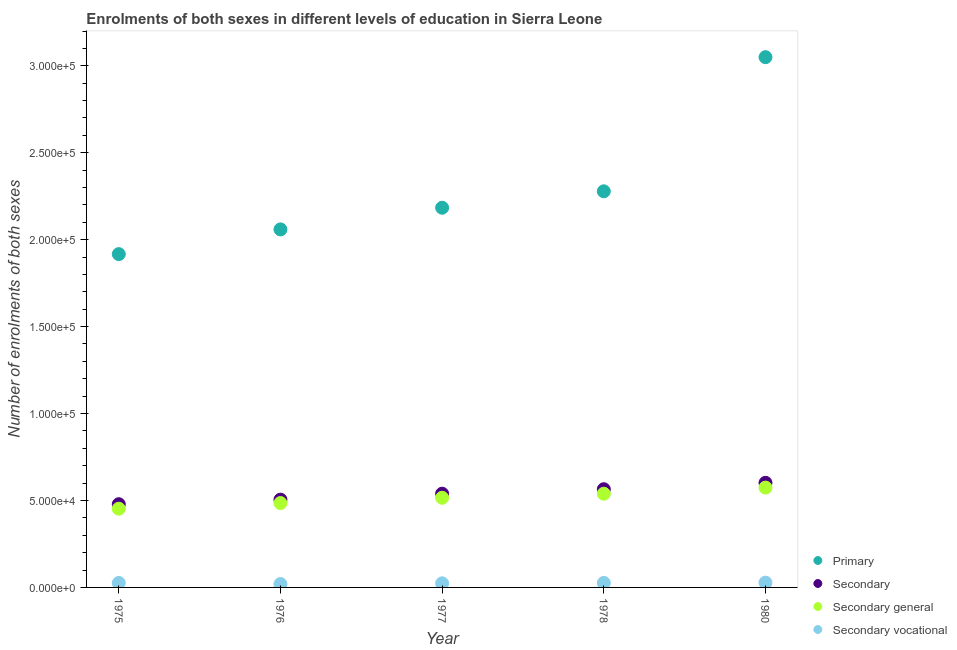How many different coloured dotlines are there?
Provide a short and direct response. 4. What is the number of enrolments in secondary education in 1976?
Offer a very short reply. 5.05e+04. Across all years, what is the maximum number of enrolments in primary education?
Provide a short and direct response. 3.05e+05. Across all years, what is the minimum number of enrolments in secondary general education?
Provide a short and direct response. 4.53e+04. In which year was the number of enrolments in primary education minimum?
Provide a succinct answer. 1975. What is the total number of enrolments in secondary general education in the graph?
Your response must be concise. 2.57e+05. What is the difference between the number of enrolments in primary education in 1977 and that in 1978?
Offer a terse response. -9439. What is the difference between the number of enrolments in secondary education in 1975 and the number of enrolments in secondary general education in 1976?
Your answer should be very brief. -673. What is the average number of enrolments in secondary general education per year?
Give a very brief answer. 5.13e+04. In the year 1980, what is the difference between the number of enrolments in secondary education and number of enrolments in secondary vocational education?
Make the answer very short. 5.74e+04. What is the ratio of the number of enrolments in secondary vocational education in 1976 to that in 1978?
Give a very brief answer. 0.75. Is the number of enrolments in secondary general education in 1977 less than that in 1980?
Your answer should be very brief. Yes. Is the difference between the number of enrolments in secondary general education in 1975 and 1980 greater than the difference between the number of enrolments in primary education in 1975 and 1980?
Offer a very short reply. Yes. What is the difference between the highest and the second highest number of enrolments in secondary general education?
Make the answer very short. 3517. What is the difference between the highest and the lowest number of enrolments in secondary general education?
Your answer should be very brief. 1.21e+04. In how many years, is the number of enrolments in secondary vocational education greater than the average number of enrolments in secondary vocational education taken over all years?
Your answer should be very brief. 3. Is the sum of the number of enrolments in secondary vocational education in 1976 and 1977 greater than the maximum number of enrolments in secondary education across all years?
Offer a terse response. No. Is it the case that in every year, the sum of the number of enrolments in primary education and number of enrolments in secondary education is greater than the number of enrolments in secondary general education?
Offer a very short reply. Yes. Does the graph contain grids?
Offer a very short reply. No. How many legend labels are there?
Give a very brief answer. 4. How are the legend labels stacked?
Your answer should be compact. Vertical. What is the title of the graph?
Ensure brevity in your answer.  Enrolments of both sexes in different levels of education in Sierra Leone. What is the label or title of the Y-axis?
Offer a very short reply. Number of enrolments of both sexes. What is the Number of enrolments of both sexes of Primary in 1975?
Offer a very short reply. 1.92e+05. What is the Number of enrolments of both sexes of Secondary in 1975?
Your answer should be compact. 4.79e+04. What is the Number of enrolments of both sexes in Secondary general in 1975?
Provide a short and direct response. 4.53e+04. What is the Number of enrolments of both sexes in Secondary vocational in 1975?
Offer a very short reply. 2584. What is the Number of enrolments of both sexes in Primary in 1976?
Provide a short and direct response. 2.06e+05. What is the Number of enrolments of both sexes in Secondary in 1976?
Ensure brevity in your answer.  5.05e+04. What is the Number of enrolments of both sexes of Secondary general in 1976?
Your answer should be compact. 4.85e+04. What is the Number of enrolments of both sexes in Secondary vocational in 1976?
Your response must be concise. 1944. What is the Number of enrolments of both sexes of Primary in 1977?
Provide a short and direct response. 2.18e+05. What is the Number of enrolments of both sexes in Secondary in 1977?
Provide a short and direct response. 5.39e+04. What is the Number of enrolments of both sexes of Secondary general in 1977?
Offer a very short reply. 5.16e+04. What is the Number of enrolments of both sexes in Secondary vocational in 1977?
Your answer should be compact. 2349. What is the Number of enrolments of both sexes in Primary in 1978?
Ensure brevity in your answer.  2.28e+05. What is the Number of enrolments of both sexes of Secondary in 1978?
Make the answer very short. 5.65e+04. What is the Number of enrolments of both sexes in Secondary general in 1978?
Provide a short and direct response. 5.39e+04. What is the Number of enrolments of both sexes in Secondary vocational in 1978?
Your answer should be compact. 2583. What is the Number of enrolments of both sexes of Primary in 1980?
Your response must be concise. 3.05e+05. What is the Number of enrolments of both sexes of Secondary in 1980?
Your response must be concise. 6.02e+04. What is the Number of enrolments of both sexes in Secondary general in 1980?
Keep it short and to the point. 5.74e+04. What is the Number of enrolments of both sexes of Secondary vocational in 1980?
Your answer should be compact. 2743. Across all years, what is the maximum Number of enrolments of both sexes of Primary?
Your answer should be very brief. 3.05e+05. Across all years, what is the maximum Number of enrolments of both sexes of Secondary?
Offer a terse response. 6.02e+04. Across all years, what is the maximum Number of enrolments of both sexes of Secondary general?
Offer a terse response. 5.74e+04. Across all years, what is the maximum Number of enrolments of both sexes of Secondary vocational?
Provide a short and direct response. 2743. Across all years, what is the minimum Number of enrolments of both sexes of Primary?
Provide a short and direct response. 1.92e+05. Across all years, what is the minimum Number of enrolments of both sexes in Secondary?
Offer a terse response. 4.79e+04. Across all years, what is the minimum Number of enrolments of both sexes in Secondary general?
Keep it short and to the point. 4.53e+04. Across all years, what is the minimum Number of enrolments of both sexes in Secondary vocational?
Keep it short and to the point. 1944. What is the total Number of enrolments of both sexes in Primary in the graph?
Provide a succinct answer. 1.15e+06. What is the total Number of enrolments of both sexes in Secondary in the graph?
Ensure brevity in your answer.  2.69e+05. What is the total Number of enrolments of both sexes in Secondary general in the graph?
Your response must be concise. 2.57e+05. What is the total Number of enrolments of both sexes of Secondary vocational in the graph?
Offer a very short reply. 1.22e+04. What is the difference between the Number of enrolments of both sexes in Primary in 1975 and that in 1976?
Offer a terse response. -1.42e+04. What is the difference between the Number of enrolments of both sexes in Secondary in 1975 and that in 1976?
Ensure brevity in your answer.  -2617. What is the difference between the Number of enrolments of both sexes of Secondary general in 1975 and that in 1976?
Give a very brief answer. -3257. What is the difference between the Number of enrolments of both sexes of Secondary vocational in 1975 and that in 1976?
Your answer should be compact. 640. What is the difference between the Number of enrolments of both sexes of Primary in 1975 and that in 1977?
Provide a succinct answer. -2.67e+04. What is the difference between the Number of enrolments of both sexes in Secondary in 1975 and that in 1977?
Make the answer very short. -6052. What is the difference between the Number of enrolments of both sexes of Secondary general in 1975 and that in 1977?
Ensure brevity in your answer.  -6287. What is the difference between the Number of enrolments of both sexes of Secondary vocational in 1975 and that in 1977?
Offer a terse response. 235. What is the difference between the Number of enrolments of both sexes of Primary in 1975 and that in 1978?
Your response must be concise. -3.61e+04. What is the difference between the Number of enrolments of both sexes of Secondary in 1975 and that in 1978?
Your answer should be compact. -8619. What is the difference between the Number of enrolments of both sexes in Secondary general in 1975 and that in 1978?
Make the answer very short. -8620. What is the difference between the Number of enrolments of both sexes in Secondary vocational in 1975 and that in 1978?
Ensure brevity in your answer.  1. What is the difference between the Number of enrolments of both sexes in Primary in 1975 and that in 1980?
Your answer should be very brief. -1.13e+05. What is the difference between the Number of enrolments of both sexes of Secondary in 1975 and that in 1980?
Give a very brief answer. -1.23e+04. What is the difference between the Number of enrolments of both sexes in Secondary general in 1975 and that in 1980?
Keep it short and to the point. -1.21e+04. What is the difference between the Number of enrolments of both sexes in Secondary vocational in 1975 and that in 1980?
Provide a succinct answer. -159. What is the difference between the Number of enrolments of both sexes of Primary in 1976 and that in 1977?
Give a very brief answer. -1.25e+04. What is the difference between the Number of enrolments of both sexes of Secondary in 1976 and that in 1977?
Give a very brief answer. -3435. What is the difference between the Number of enrolments of both sexes in Secondary general in 1976 and that in 1977?
Give a very brief answer. -3030. What is the difference between the Number of enrolments of both sexes of Secondary vocational in 1976 and that in 1977?
Your answer should be compact. -405. What is the difference between the Number of enrolments of both sexes of Primary in 1976 and that in 1978?
Provide a succinct answer. -2.19e+04. What is the difference between the Number of enrolments of both sexes in Secondary in 1976 and that in 1978?
Ensure brevity in your answer.  -6002. What is the difference between the Number of enrolments of both sexes in Secondary general in 1976 and that in 1978?
Your answer should be very brief. -5363. What is the difference between the Number of enrolments of both sexes of Secondary vocational in 1976 and that in 1978?
Provide a short and direct response. -639. What is the difference between the Number of enrolments of both sexes of Primary in 1976 and that in 1980?
Give a very brief answer. -9.91e+04. What is the difference between the Number of enrolments of both sexes in Secondary in 1976 and that in 1980?
Your answer should be compact. -9679. What is the difference between the Number of enrolments of both sexes of Secondary general in 1976 and that in 1980?
Ensure brevity in your answer.  -8880. What is the difference between the Number of enrolments of both sexes in Secondary vocational in 1976 and that in 1980?
Provide a succinct answer. -799. What is the difference between the Number of enrolments of both sexes in Primary in 1977 and that in 1978?
Ensure brevity in your answer.  -9439. What is the difference between the Number of enrolments of both sexes of Secondary in 1977 and that in 1978?
Make the answer very short. -2567. What is the difference between the Number of enrolments of both sexes of Secondary general in 1977 and that in 1978?
Ensure brevity in your answer.  -2333. What is the difference between the Number of enrolments of both sexes of Secondary vocational in 1977 and that in 1978?
Offer a very short reply. -234. What is the difference between the Number of enrolments of both sexes in Primary in 1977 and that in 1980?
Keep it short and to the point. -8.66e+04. What is the difference between the Number of enrolments of both sexes of Secondary in 1977 and that in 1980?
Your answer should be compact. -6244. What is the difference between the Number of enrolments of both sexes of Secondary general in 1977 and that in 1980?
Your answer should be very brief. -5850. What is the difference between the Number of enrolments of both sexes of Secondary vocational in 1977 and that in 1980?
Provide a short and direct response. -394. What is the difference between the Number of enrolments of both sexes in Primary in 1978 and that in 1980?
Give a very brief answer. -7.71e+04. What is the difference between the Number of enrolments of both sexes of Secondary in 1978 and that in 1980?
Keep it short and to the point. -3677. What is the difference between the Number of enrolments of both sexes in Secondary general in 1978 and that in 1980?
Keep it short and to the point. -3517. What is the difference between the Number of enrolments of both sexes of Secondary vocational in 1978 and that in 1980?
Offer a very short reply. -160. What is the difference between the Number of enrolments of both sexes in Primary in 1975 and the Number of enrolments of both sexes in Secondary in 1976?
Your response must be concise. 1.41e+05. What is the difference between the Number of enrolments of both sexes in Primary in 1975 and the Number of enrolments of both sexes in Secondary general in 1976?
Provide a short and direct response. 1.43e+05. What is the difference between the Number of enrolments of both sexes of Primary in 1975 and the Number of enrolments of both sexes of Secondary vocational in 1976?
Your answer should be very brief. 1.90e+05. What is the difference between the Number of enrolments of both sexes of Secondary in 1975 and the Number of enrolments of both sexes of Secondary general in 1976?
Make the answer very short. -673. What is the difference between the Number of enrolments of both sexes of Secondary in 1975 and the Number of enrolments of both sexes of Secondary vocational in 1976?
Your answer should be very brief. 4.59e+04. What is the difference between the Number of enrolments of both sexes in Secondary general in 1975 and the Number of enrolments of both sexes in Secondary vocational in 1976?
Provide a short and direct response. 4.33e+04. What is the difference between the Number of enrolments of both sexes of Primary in 1975 and the Number of enrolments of both sexes of Secondary in 1977?
Your answer should be very brief. 1.38e+05. What is the difference between the Number of enrolments of both sexes in Primary in 1975 and the Number of enrolments of both sexes in Secondary general in 1977?
Your answer should be very brief. 1.40e+05. What is the difference between the Number of enrolments of both sexes of Primary in 1975 and the Number of enrolments of both sexes of Secondary vocational in 1977?
Offer a terse response. 1.89e+05. What is the difference between the Number of enrolments of both sexes in Secondary in 1975 and the Number of enrolments of both sexes in Secondary general in 1977?
Keep it short and to the point. -3703. What is the difference between the Number of enrolments of both sexes in Secondary in 1975 and the Number of enrolments of both sexes in Secondary vocational in 1977?
Your response must be concise. 4.55e+04. What is the difference between the Number of enrolments of both sexes in Secondary general in 1975 and the Number of enrolments of both sexes in Secondary vocational in 1977?
Your answer should be very brief. 4.29e+04. What is the difference between the Number of enrolments of both sexes of Primary in 1975 and the Number of enrolments of both sexes of Secondary in 1978?
Your answer should be very brief. 1.35e+05. What is the difference between the Number of enrolments of both sexes in Primary in 1975 and the Number of enrolments of both sexes in Secondary general in 1978?
Offer a very short reply. 1.38e+05. What is the difference between the Number of enrolments of both sexes of Primary in 1975 and the Number of enrolments of both sexes of Secondary vocational in 1978?
Offer a very short reply. 1.89e+05. What is the difference between the Number of enrolments of both sexes in Secondary in 1975 and the Number of enrolments of both sexes in Secondary general in 1978?
Offer a very short reply. -6036. What is the difference between the Number of enrolments of both sexes in Secondary in 1975 and the Number of enrolments of both sexes in Secondary vocational in 1978?
Ensure brevity in your answer.  4.53e+04. What is the difference between the Number of enrolments of both sexes of Secondary general in 1975 and the Number of enrolments of both sexes of Secondary vocational in 1978?
Make the answer very short. 4.27e+04. What is the difference between the Number of enrolments of both sexes in Primary in 1975 and the Number of enrolments of both sexes in Secondary in 1980?
Provide a succinct answer. 1.32e+05. What is the difference between the Number of enrolments of both sexes of Primary in 1975 and the Number of enrolments of both sexes of Secondary general in 1980?
Offer a terse response. 1.34e+05. What is the difference between the Number of enrolments of both sexes of Primary in 1975 and the Number of enrolments of both sexes of Secondary vocational in 1980?
Keep it short and to the point. 1.89e+05. What is the difference between the Number of enrolments of both sexes in Secondary in 1975 and the Number of enrolments of both sexes in Secondary general in 1980?
Provide a succinct answer. -9553. What is the difference between the Number of enrolments of both sexes of Secondary in 1975 and the Number of enrolments of both sexes of Secondary vocational in 1980?
Keep it short and to the point. 4.51e+04. What is the difference between the Number of enrolments of both sexes of Secondary general in 1975 and the Number of enrolments of both sexes of Secondary vocational in 1980?
Offer a very short reply. 4.25e+04. What is the difference between the Number of enrolments of both sexes in Primary in 1976 and the Number of enrolments of both sexes in Secondary in 1977?
Give a very brief answer. 1.52e+05. What is the difference between the Number of enrolments of both sexes of Primary in 1976 and the Number of enrolments of both sexes of Secondary general in 1977?
Keep it short and to the point. 1.54e+05. What is the difference between the Number of enrolments of both sexes of Primary in 1976 and the Number of enrolments of both sexes of Secondary vocational in 1977?
Ensure brevity in your answer.  2.04e+05. What is the difference between the Number of enrolments of both sexes in Secondary in 1976 and the Number of enrolments of both sexes in Secondary general in 1977?
Provide a succinct answer. -1086. What is the difference between the Number of enrolments of both sexes of Secondary in 1976 and the Number of enrolments of both sexes of Secondary vocational in 1977?
Provide a short and direct response. 4.81e+04. What is the difference between the Number of enrolments of both sexes in Secondary general in 1976 and the Number of enrolments of both sexes in Secondary vocational in 1977?
Provide a succinct answer. 4.62e+04. What is the difference between the Number of enrolments of both sexes of Primary in 1976 and the Number of enrolments of both sexes of Secondary in 1978?
Your response must be concise. 1.49e+05. What is the difference between the Number of enrolments of both sexes of Primary in 1976 and the Number of enrolments of both sexes of Secondary general in 1978?
Make the answer very short. 1.52e+05. What is the difference between the Number of enrolments of both sexes in Primary in 1976 and the Number of enrolments of both sexes in Secondary vocational in 1978?
Your answer should be compact. 2.03e+05. What is the difference between the Number of enrolments of both sexes of Secondary in 1976 and the Number of enrolments of both sexes of Secondary general in 1978?
Your answer should be very brief. -3419. What is the difference between the Number of enrolments of both sexes of Secondary in 1976 and the Number of enrolments of both sexes of Secondary vocational in 1978?
Give a very brief answer. 4.79e+04. What is the difference between the Number of enrolments of both sexes in Secondary general in 1976 and the Number of enrolments of both sexes in Secondary vocational in 1978?
Offer a very short reply. 4.60e+04. What is the difference between the Number of enrolments of both sexes of Primary in 1976 and the Number of enrolments of both sexes of Secondary in 1980?
Give a very brief answer. 1.46e+05. What is the difference between the Number of enrolments of both sexes of Primary in 1976 and the Number of enrolments of both sexes of Secondary general in 1980?
Your answer should be very brief. 1.48e+05. What is the difference between the Number of enrolments of both sexes in Primary in 1976 and the Number of enrolments of both sexes in Secondary vocational in 1980?
Ensure brevity in your answer.  2.03e+05. What is the difference between the Number of enrolments of both sexes in Secondary in 1976 and the Number of enrolments of both sexes in Secondary general in 1980?
Provide a succinct answer. -6936. What is the difference between the Number of enrolments of both sexes of Secondary in 1976 and the Number of enrolments of both sexes of Secondary vocational in 1980?
Make the answer very short. 4.77e+04. What is the difference between the Number of enrolments of both sexes of Secondary general in 1976 and the Number of enrolments of both sexes of Secondary vocational in 1980?
Give a very brief answer. 4.58e+04. What is the difference between the Number of enrolments of both sexes of Primary in 1977 and the Number of enrolments of both sexes of Secondary in 1978?
Provide a short and direct response. 1.62e+05. What is the difference between the Number of enrolments of both sexes in Primary in 1977 and the Number of enrolments of both sexes in Secondary general in 1978?
Your answer should be compact. 1.64e+05. What is the difference between the Number of enrolments of both sexes in Primary in 1977 and the Number of enrolments of both sexes in Secondary vocational in 1978?
Offer a very short reply. 2.16e+05. What is the difference between the Number of enrolments of both sexes in Secondary in 1977 and the Number of enrolments of both sexes in Secondary general in 1978?
Make the answer very short. 16. What is the difference between the Number of enrolments of both sexes in Secondary in 1977 and the Number of enrolments of both sexes in Secondary vocational in 1978?
Ensure brevity in your answer.  5.13e+04. What is the difference between the Number of enrolments of both sexes of Secondary general in 1977 and the Number of enrolments of both sexes of Secondary vocational in 1978?
Offer a very short reply. 4.90e+04. What is the difference between the Number of enrolments of both sexes in Primary in 1977 and the Number of enrolments of both sexes in Secondary in 1980?
Your response must be concise. 1.58e+05. What is the difference between the Number of enrolments of both sexes in Primary in 1977 and the Number of enrolments of both sexes in Secondary general in 1980?
Provide a succinct answer. 1.61e+05. What is the difference between the Number of enrolments of both sexes of Primary in 1977 and the Number of enrolments of both sexes of Secondary vocational in 1980?
Your answer should be compact. 2.16e+05. What is the difference between the Number of enrolments of both sexes of Secondary in 1977 and the Number of enrolments of both sexes of Secondary general in 1980?
Provide a succinct answer. -3501. What is the difference between the Number of enrolments of both sexes of Secondary in 1977 and the Number of enrolments of both sexes of Secondary vocational in 1980?
Your response must be concise. 5.12e+04. What is the difference between the Number of enrolments of both sexes in Secondary general in 1977 and the Number of enrolments of both sexes in Secondary vocational in 1980?
Keep it short and to the point. 4.88e+04. What is the difference between the Number of enrolments of both sexes of Primary in 1978 and the Number of enrolments of both sexes of Secondary in 1980?
Your response must be concise. 1.68e+05. What is the difference between the Number of enrolments of both sexes in Primary in 1978 and the Number of enrolments of both sexes in Secondary general in 1980?
Your answer should be very brief. 1.70e+05. What is the difference between the Number of enrolments of both sexes in Primary in 1978 and the Number of enrolments of both sexes in Secondary vocational in 1980?
Offer a terse response. 2.25e+05. What is the difference between the Number of enrolments of both sexes of Secondary in 1978 and the Number of enrolments of both sexes of Secondary general in 1980?
Your answer should be compact. -934. What is the difference between the Number of enrolments of both sexes of Secondary in 1978 and the Number of enrolments of both sexes of Secondary vocational in 1980?
Your answer should be very brief. 5.37e+04. What is the difference between the Number of enrolments of both sexes of Secondary general in 1978 and the Number of enrolments of both sexes of Secondary vocational in 1980?
Ensure brevity in your answer.  5.12e+04. What is the average Number of enrolments of both sexes of Primary per year?
Give a very brief answer. 2.30e+05. What is the average Number of enrolments of both sexes of Secondary per year?
Provide a short and direct response. 5.38e+04. What is the average Number of enrolments of both sexes of Secondary general per year?
Keep it short and to the point. 5.13e+04. What is the average Number of enrolments of both sexes of Secondary vocational per year?
Keep it short and to the point. 2440.6. In the year 1975, what is the difference between the Number of enrolments of both sexes in Primary and Number of enrolments of both sexes in Secondary?
Provide a succinct answer. 1.44e+05. In the year 1975, what is the difference between the Number of enrolments of both sexes of Primary and Number of enrolments of both sexes of Secondary general?
Your answer should be compact. 1.46e+05. In the year 1975, what is the difference between the Number of enrolments of both sexes of Primary and Number of enrolments of both sexes of Secondary vocational?
Provide a short and direct response. 1.89e+05. In the year 1975, what is the difference between the Number of enrolments of both sexes of Secondary and Number of enrolments of both sexes of Secondary general?
Keep it short and to the point. 2584. In the year 1975, what is the difference between the Number of enrolments of both sexes in Secondary and Number of enrolments of both sexes in Secondary vocational?
Provide a succinct answer. 4.53e+04. In the year 1975, what is the difference between the Number of enrolments of both sexes of Secondary general and Number of enrolments of both sexes of Secondary vocational?
Ensure brevity in your answer.  4.27e+04. In the year 1976, what is the difference between the Number of enrolments of both sexes in Primary and Number of enrolments of both sexes in Secondary?
Your answer should be compact. 1.55e+05. In the year 1976, what is the difference between the Number of enrolments of both sexes of Primary and Number of enrolments of both sexes of Secondary general?
Offer a very short reply. 1.57e+05. In the year 1976, what is the difference between the Number of enrolments of both sexes in Primary and Number of enrolments of both sexes in Secondary vocational?
Your answer should be very brief. 2.04e+05. In the year 1976, what is the difference between the Number of enrolments of both sexes of Secondary and Number of enrolments of both sexes of Secondary general?
Keep it short and to the point. 1944. In the year 1976, what is the difference between the Number of enrolments of both sexes of Secondary and Number of enrolments of both sexes of Secondary vocational?
Make the answer very short. 4.85e+04. In the year 1976, what is the difference between the Number of enrolments of both sexes in Secondary general and Number of enrolments of both sexes in Secondary vocational?
Provide a succinct answer. 4.66e+04. In the year 1977, what is the difference between the Number of enrolments of both sexes of Primary and Number of enrolments of both sexes of Secondary?
Your answer should be compact. 1.64e+05. In the year 1977, what is the difference between the Number of enrolments of both sexes in Primary and Number of enrolments of both sexes in Secondary general?
Your answer should be compact. 1.67e+05. In the year 1977, what is the difference between the Number of enrolments of both sexes in Primary and Number of enrolments of both sexes in Secondary vocational?
Your answer should be compact. 2.16e+05. In the year 1977, what is the difference between the Number of enrolments of both sexes in Secondary and Number of enrolments of both sexes in Secondary general?
Keep it short and to the point. 2349. In the year 1977, what is the difference between the Number of enrolments of both sexes of Secondary and Number of enrolments of both sexes of Secondary vocational?
Keep it short and to the point. 5.16e+04. In the year 1977, what is the difference between the Number of enrolments of both sexes of Secondary general and Number of enrolments of both sexes of Secondary vocational?
Make the answer very short. 4.92e+04. In the year 1978, what is the difference between the Number of enrolments of both sexes of Primary and Number of enrolments of both sexes of Secondary?
Offer a very short reply. 1.71e+05. In the year 1978, what is the difference between the Number of enrolments of both sexes in Primary and Number of enrolments of both sexes in Secondary general?
Provide a succinct answer. 1.74e+05. In the year 1978, what is the difference between the Number of enrolments of both sexes of Primary and Number of enrolments of both sexes of Secondary vocational?
Give a very brief answer. 2.25e+05. In the year 1978, what is the difference between the Number of enrolments of both sexes of Secondary and Number of enrolments of both sexes of Secondary general?
Keep it short and to the point. 2583. In the year 1978, what is the difference between the Number of enrolments of both sexes in Secondary and Number of enrolments of both sexes in Secondary vocational?
Offer a very short reply. 5.39e+04. In the year 1978, what is the difference between the Number of enrolments of both sexes in Secondary general and Number of enrolments of both sexes in Secondary vocational?
Your response must be concise. 5.13e+04. In the year 1980, what is the difference between the Number of enrolments of both sexes of Primary and Number of enrolments of both sexes of Secondary?
Your answer should be very brief. 2.45e+05. In the year 1980, what is the difference between the Number of enrolments of both sexes of Primary and Number of enrolments of both sexes of Secondary general?
Ensure brevity in your answer.  2.48e+05. In the year 1980, what is the difference between the Number of enrolments of both sexes in Primary and Number of enrolments of both sexes in Secondary vocational?
Keep it short and to the point. 3.02e+05. In the year 1980, what is the difference between the Number of enrolments of both sexes in Secondary and Number of enrolments of both sexes in Secondary general?
Keep it short and to the point. 2743. In the year 1980, what is the difference between the Number of enrolments of both sexes of Secondary and Number of enrolments of both sexes of Secondary vocational?
Offer a very short reply. 5.74e+04. In the year 1980, what is the difference between the Number of enrolments of both sexes of Secondary general and Number of enrolments of both sexes of Secondary vocational?
Your answer should be compact. 5.47e+04. What is the ratio of the Number of enrolments of both sexes in Primary in 1975 to that in 1976?
Give a very brief answer. 0.93. What is the ratio of the Number of enrolments of both sexes in Secondary in 1975 to that in 1976?
Offer a very short reply. 0.95. What is the ratio of the Number of enrolments of both sexes in Secondary general in 1975 to that in 1976?
Your answer should be compact. 0.93. What is the ratio of the Number of enrolments of both sexes of Secondary vocational in 1975 to that in 1976?
Provide a succinct answer. 1.33. What is the ratio of the Number of enrolments of both sexes in Primary in 1975 to that in 1977?
Your answer should be compact. 0.88. What is the ratio of the Number of enrolments of both sexes in Secondary in 1975 to that in 1977?
Offer a terse response. 0.89. What is the ratio of the Number of enrolments of both sexes in Secondary general in 1975 to that in 1977?
Make the answer very short. 0.88. What is the ratio of the Number of enrolments of both sexes of Primary in 1975 to that in 1978?
Make the answer very short. 0.84. What is the ratio of the Number of enrolments of both sexes in Secondary in 1975 to that in 1978?
Offer a very short reply. 0.85. What is the ratio of the Number of enrolments of both sexes of Secondary general in 1975 to that in 1978?
Keep it short and to the point. 0.84. What is the ratio of the Number of enrolments of both sexes in Primary in 1975 to that in 1980?
Keep it short and to the point. 0.63. What is the ratio of the Number of enrolments of both sexes in Secondary in 1975 to that in 1980?
Your answer should be very brief. 0.8. What is the ratio of the Number of enrolments of both sexes in Secondary general in 1975 to that in 1980?
Provide a succinct answer. 0.79. What is the ratio of the Number of enrolments of both sexes of Secondary vocational in 1975 to that in 1980?
Keep it short and to the point. 0.94. What is the ratio of the Number of enrolments of both sexes of Primary in 1976 to that in 1977?
Offer a terse response. 0.94. What is the ratio of the Number of enrolments of both sexes in Secondary in 1976 to that in 1977?
Give a very brief answer. 0.94. What is the ratio of the Number of enrolments of both sexes in Secondary general in 1976 to that in 1977?
Provide a succinct answer. 0.94. What is the ratio of the Number of enrolments of both sexes of Secondary vocational in 1976 to that in 1977?
Offer a terse response. 0.83. What is the ratio of the Number of enrolments of both sexes in Primary in 1976 to that in 1978?
Offer a terse response. 0.9. What is the ratio of the Number of enrolments of both sexes of Secondary in 1976 to that in 1978?
Make the answer very short. 0.89. What is the ratio of the Number of enrolments of both sexes in Secondary general in 1976 to that in 1978?
Give a very brief answer. 0.9. What is the ratio of the Number of enrolments of both sexes in Secondary vocational in 1976 to that in 1978?
Offer a very short reply. 0.75. What is the ratio of the Number of enrolments of both sexes in Primary in 1976 to that in 1980?
Offer a terse response. 0.68. What is the ratio of the Number of enrolments of both sexes in Secondary in 1976 to that in 1980?
Offer a terse response. 0.84. What is the ratio of the Number of enrolments of both sexes in Secondary general in 1976 to that in 1980?
Offer a very short reply. 0.85. What is the ratio of the Number of enrolments of both sexes in Secondary vocational in 1976 to that in 1980?
Provide a succinct answer. 0.71. What is the ratio of the Number of enrolments of both sexes in Primary in 1977 to that in 1978?
Offer a very short reply. 0.96. What is the ratio of the Number of enrolments of both sexes in Secondary in 1977 to that in 1978?
Keep it short and to the point. 0.95. What is the ratio of the Number of enrolments of both sexes in Secondary general in 1977 to that in 1978?
Provide a succinct answer. 0.96. What is the ratio of the Number of enrolments of both sexes of Secondary vocational in 1977 to that in 1978?
Provide a short and direct response. 0.91. What is the ratio of the Number of enrolments of both sexes in Primary in 1977 to that in 1980?
Make the answer very short. 0.72. What is the ratio of the Number of enrolments of both sexes of Secondary in 1977 to that in 1980?
Provide a succinct answer. 0.9. What is the ratio of the Number of enrolments of both sexes in Secondary general in 1977 to that in 1980?
Make the answer very short. 0.9. What is the ratio of the Number of enrolments of both sexes of Secondary vocational in 1977 to that in 1980?
Keep it short and to the point. 0.86. What is the ratio of the Number of enrolments of both sexes in Primary in 1978 to that in 1980?
Your answer should be very brief. 0.75. What is the ratio of the Number of enrolments of both sexes of Secondary in 1978 to that in 1980?
Provide a succinct answer. 0.94. What is the ratio of the Number of enrolments of both sexes of Secondary general in 1978 to that in 1980?
Provide a short and direct response. 0.94. What is the ratio of the Number of enrolments of both sexes of Secondary vocational in 1978 to that in 1980?
Provide a short and direct response. 0.94. What is the difference between the highest and the second highest Number of enrolments of both sexes of Primary?
Your answer should be compact. 7.71e+04. What is the difference between the highest and the second highest Number of enrolments of both sexes in Secondary?
Provide a short and direct response. 3677. What is the difference between the highest and the second highest Number of enrolments of both sexes in Secondary general?
Keep it short and to the point. 3517. What is the difference between the highest and the second highest Number of enrolments of both sexes in Secondary vocational?
Provide a succinct answer. 159. What is the difference between the highest and the lowest Number of enrolments of both sexes of Primary?
Your answer should be compact. 1.13e+05. What is the difference between the highest and the lowest Number of enrolments of both sexes in Secondary?
Ensure brevity in your answer.  1.23e+04. What is the difference between the highest and the lowest Number of enrolments of both sexes of Secondary general?
Provide a succinct answer. 1.21e+04. What is the difference between the highest and the lowest Number of enrolments of both sexes of Secondary vocational?
Ensure brevity in your answer.  799. 